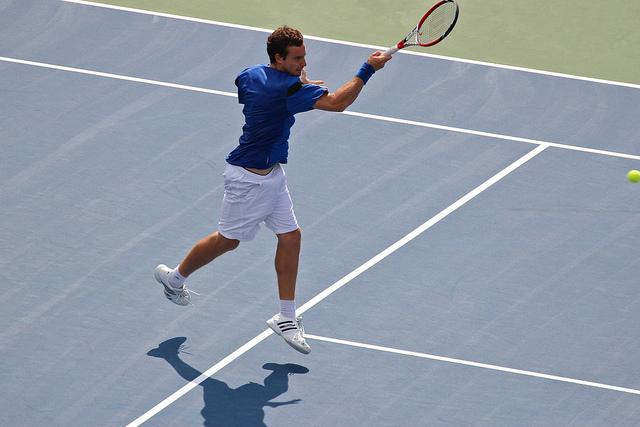What color are the man's shoes?
Answer briefly. White. Do you see a shadow?
Concise answer only. Yes. What are the color of his shorts?
Write a very short answer. White. Is the man wearing pants?
Short answer required. No. Is this man serving?
Concise answer only. No. 